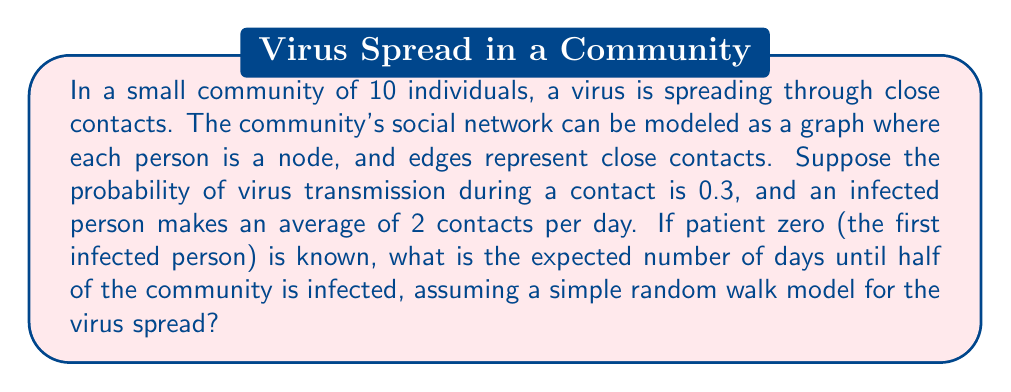What is the answer to this math problem? Let's approach this step-by-step:

1) First, we need to understand the random walk model on this graph:
   - Each day, an infected person makes an average of 2 contacts.
   - The probability of transmission per contact is 0.3.

2) The probability of infecting a new person per day can be calculated as:
   $P(\text{new infection}) = 1 - (1 - 0.3)^2 = 0.51$

3) We can model this as a Markov chain where the states represent the number of infected people (1 to 5, as we're interested in reaching half the population).

4) The transition probability matrix $P$ would be:

   $$P = \begin{bmatrix}
   0.49 & 0.51 & 0 & 0 & 0 \\
   0 & 0.2401 & 0.7599 & 0 & 0 \\
   0 & 0 & 0.1176 & 0.8824 & 0 \\
   0 & 0 & 0 & 0.0576 & 0.9424 \\
   0 & 0 & 0 & 0 & 1
   \end{bmatrix}$$

5) To find the expected number of days, we need to calculate the fundamental matrix $N$:
   
   $N = (I - Q)^{-1}$, where $Q$ is $P$ without the last row and column.

6) Calculating $N$:

   $$N \approx \begin{bmatrix}
   2.0408 & 2.1224 & 2.4082 & 2.5510 \\
   0 & 1.3159 & 1.4932 & 1.5827 \\
   0 & 0 & 1.1331 & 1.2007 \\
   0 & 0 & 0 & 1.0612
   \end{bmatrix}$$

7) The expected number of steps to absorption (reaching state 5) from state 1 is the sum of the first row of $N$:

   $E[\text{days}] = 2.0408 + 2.1224 + 2.4082 + 2.5510 = 9.1224$

Therefore, the expected number of days until half of the community is infected is approximately 9.12 days.
Answer: 9.12 days 